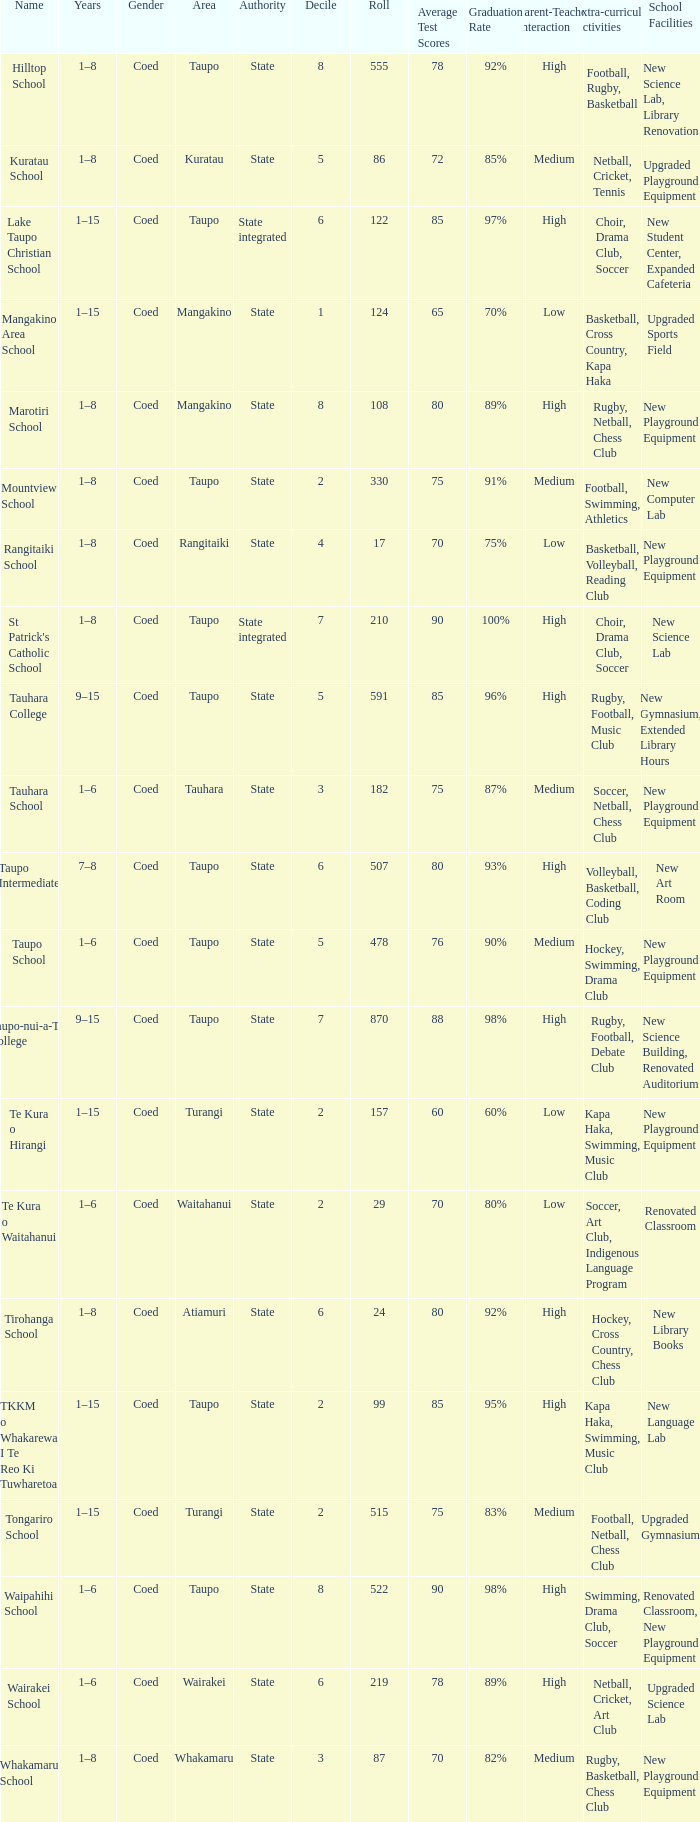Where is the school with state authority that has a roll of more than 157 students? Taupo, Taupo, Taupo, Tauhara, Taupo, Taupo, Taupo, Turangi, Taupo, Wairakei. 